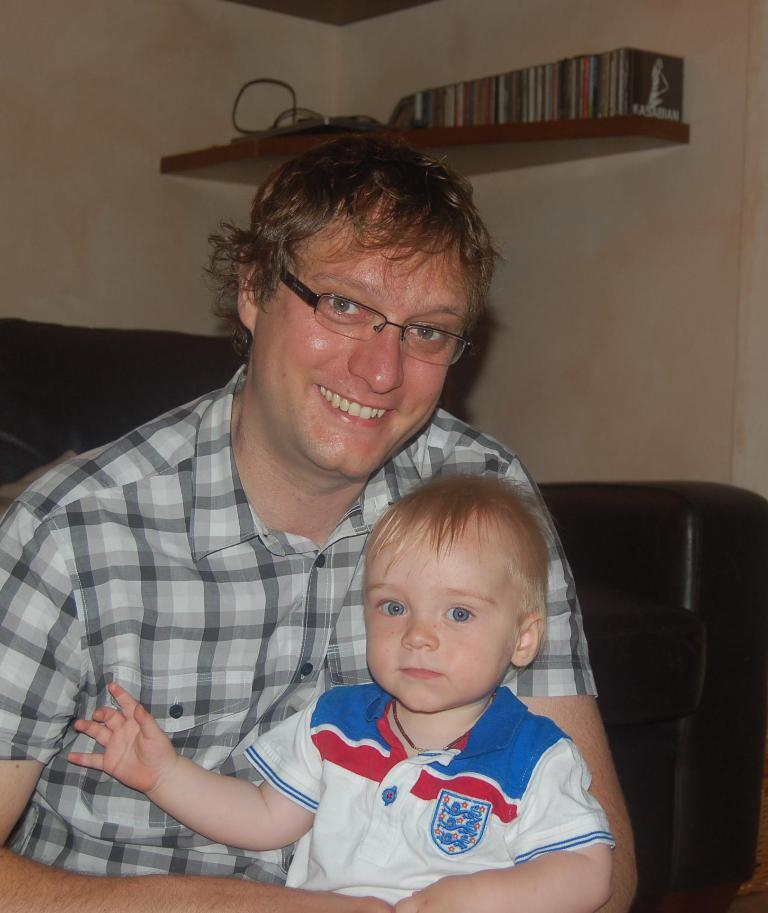Who is the main subject in the image? There is a man in the image. What is the man doing in the image? The man is holding a kid. What can be seen in the background of the image? There is a wall and a shelf in the background of the image. Are there any other objects visible in the background? Yes, there are other objects visible in the background of the image. What type of umbrella is the giraffe using in the image? There is no giraffe or umbrella present in the image. Is the army visible in the image? There is no army or any military-related elements present in the image. 